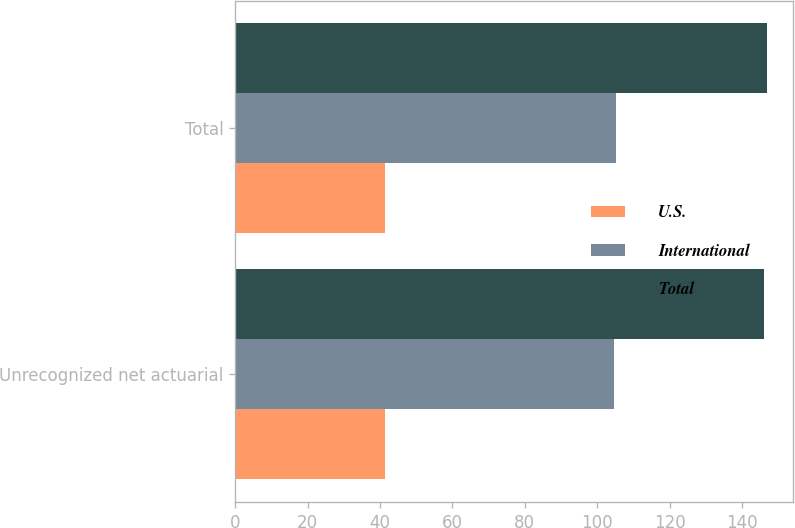Convert chart to OTSL. <chart><loc_0><loc_0><loc_500><loc_500><stacked_bar_chart><ecel><fcel>Unrecognized net actuarial<fcel>Total<nl><fcel>U.S.<fcel>41.4<fcel>41.5<nl><fcel>International<fcel>104.7<fcel>105.3<nl><fcel>Total<fcel>146.1<fcel>146.8<nl></chart> 